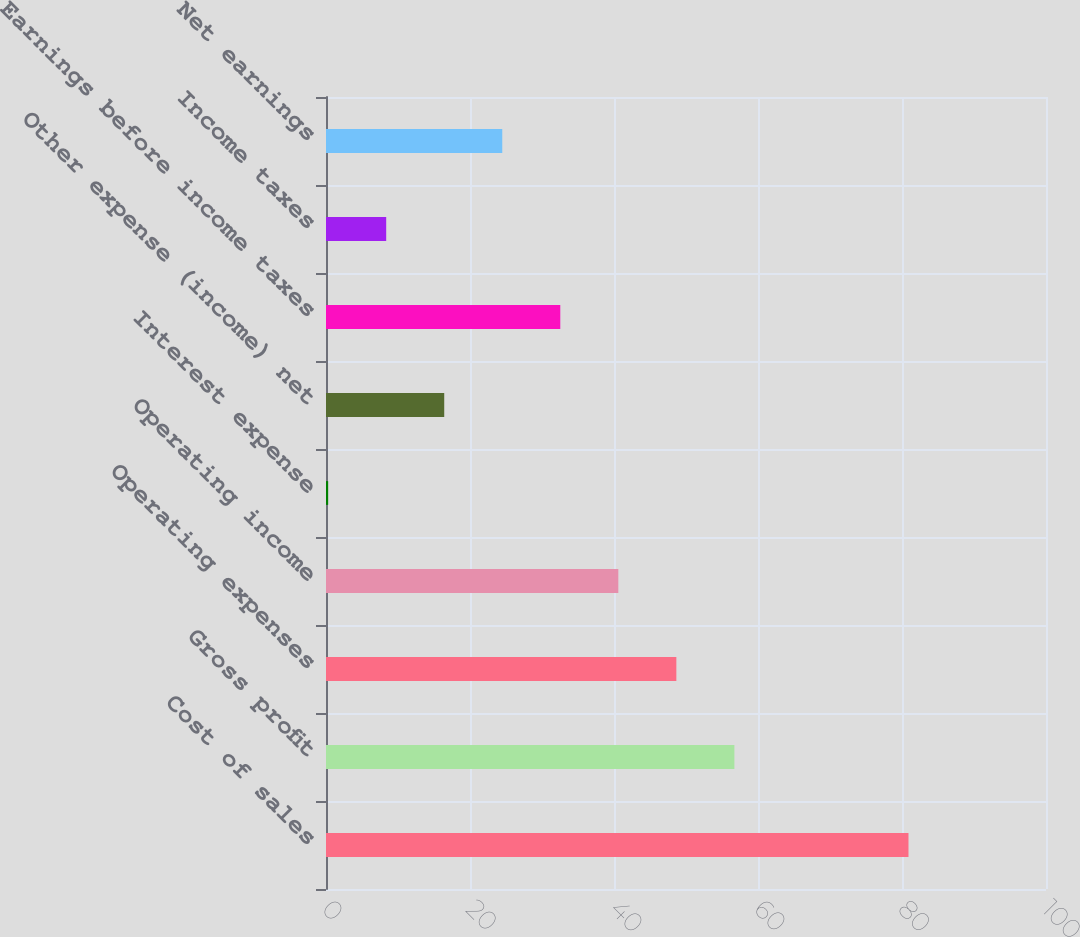<chart> <loc_0><loc_0><loc_500><loc_500><bar_chart><fcel>Cost of sales<fcel>Gross profit<fcel>Operating expenses<fcel>Operating income<fcel>Interest expense<fcel>Other expense (income) net<fcel>Earnings before income taxes<fcel>Income taxes<fcel>Net earnings<nl><fcel>80.9<fcel>56.72<fcel>48.66<fcel>40.6<fcel>0.3<fcel>16.42<fcel>32.54<fcel>8.36<fcel>24.48<nl></chart> 